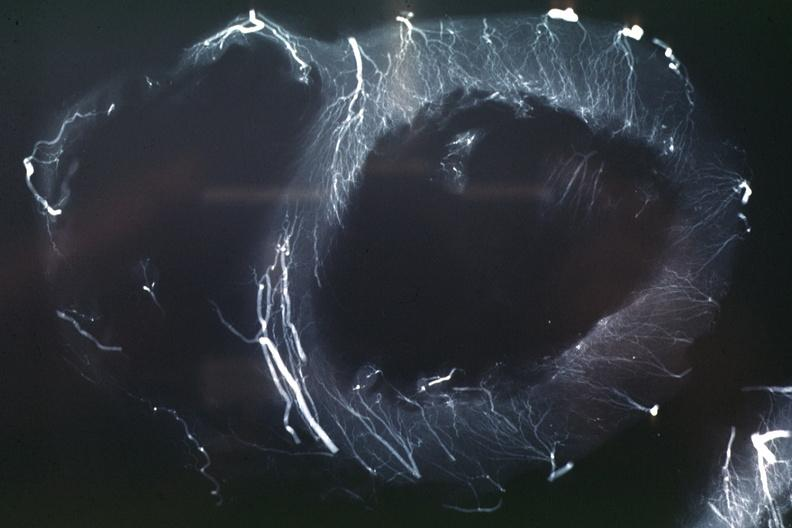s siamese twins present?
Answer the question using a single word or phrase. No 